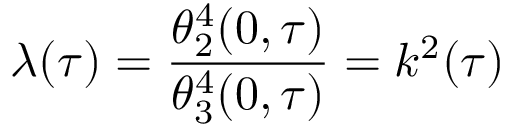Convert formula to latex. <formula><loc_0><loc_0><loc_500><loc_500>\lambda ( \tau ) = { \frac { \theta _ { 2 } ^ { 4 } ( 0 , \tau ) } { \theta _ { 3 } ^ { 4 } ( 0 , \tau ) } } = k ^ { 2 } ( \tau )</formula> 